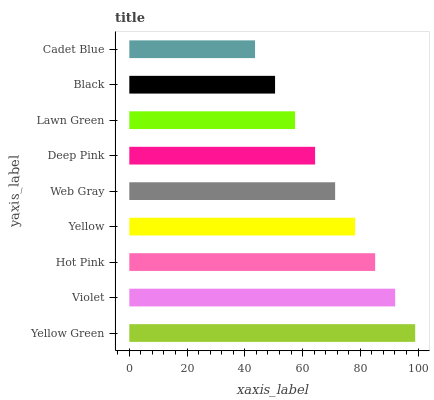Is Cadet Blue the minimum?
Answer yes or no. Yes. Is Yellow Green the maximum?
Answer yes or no. Yes. Is Violet the minimum?
Answer yes or no. No. Is Violet the maximum?
Answer yes or no. No. Is Yellow Green greater than Violet?
Answer yes or no. Yes. Is Violet less than Yellow Green?
Answer yes or no. Yes. Is Violet greater than Yellow Green?
Answer yes or no. No. Is Yellow Green less than Violet?
Answer yes or no. No. Is Web Gray the high median?
Answer yes or no. Yes. Is Web Gray the low median?
Answer yes or no. Yes. Is Yellow Green the high median?
Answer yes or no. No. Is Violet the low median?
Answer yes or no. No. 